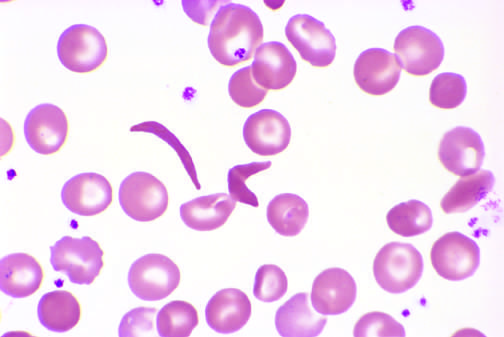what does higher magnification show in the center?
Answer the question using a single word or phrase. An irreversibly sickled cell 